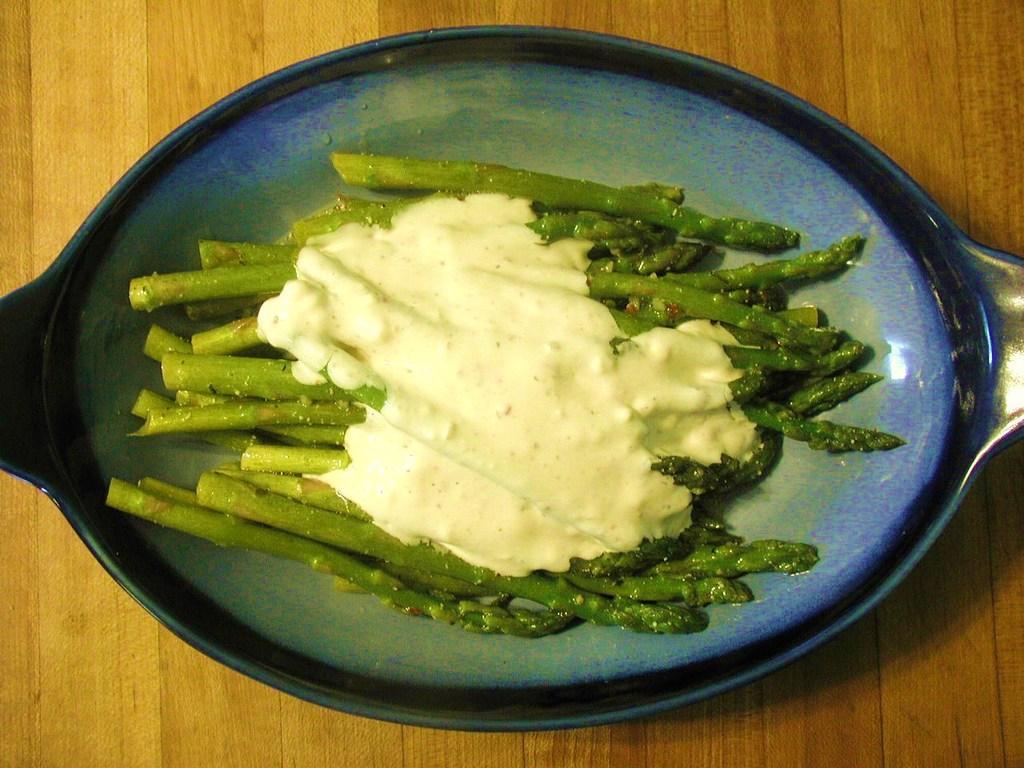Please provide a concise description of this image. In this picture we can see a bowl on the wooden surface with food items in it. 